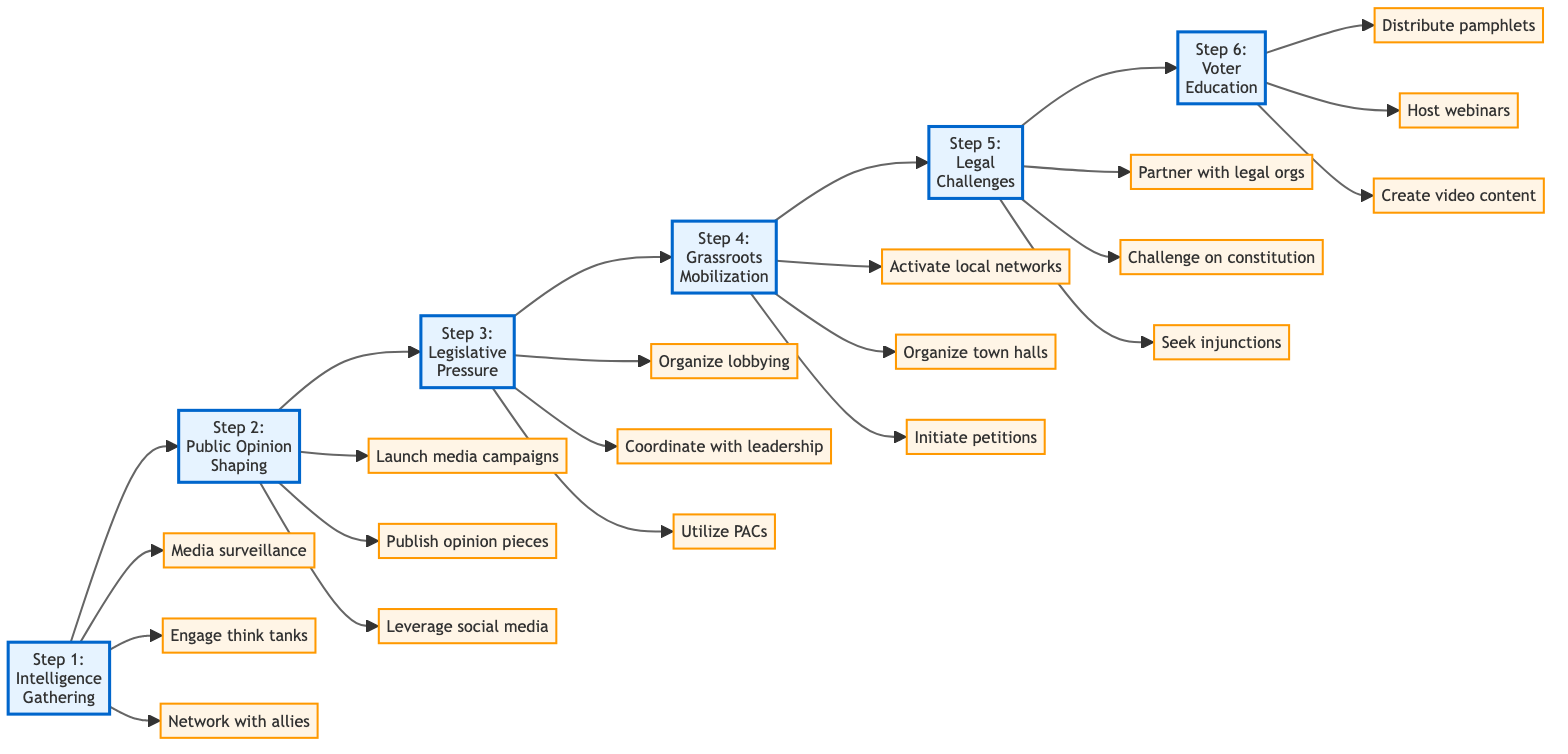What is the first step in counteracting electoral reform proposals? The first step is labeled "Step 1: Intelligence Gathering," as it appears at the beginning of the flowchart.
Answer: Intelligence Gathering How many steps are there in the diagram? By counting the nodes connected horizontally in the flowchart, we can see there are six steps.
Answer: 6 What action is associated with Step 3? In Step 3, the actions listed include organizing lobbying efforts, coordinating with leadership, and utilizing PACs, identifying any of these actions will respond to the question.
Answer: Organize lobbying Which step comes after Step 4? By looking at the flow from Step 4, it flows directly to Step 5 which is labeled "Legal Challenges."
Answer: Legal Challenges What is the overall goal of the flowchart? The flowchart guides the user through steps to counteract electoral reform proposals, indicating that the aim is to resist proposed changes to the electoral system.
Answer: Counteract electoral reforms How does Step 2 relate to public opinion? Step 2 is explicitly focused on shaping public opinion, indicating its central role in creating resistance against proposed reforms.
Answer: Shape public opinion What is the last action taken in the process? The last action linked to Step 6 is "Create educational content for YouTube and other video platforms,” marking it as the final action in the flowchart.
Answer: Create educational content What step includes grassroots mobilization? Grassroots mobilization is encapsulated in Step 4, which directly addresses mobilizing community action against electoral reforms.
Answer: Step 4 What kind of organizations are suggested in Step 5 for legal challenges? Partnering with conservative legal organizations such as the Federalist Society is suggested in Step 5 for pursuing legal challenges against reforms.
Answer: Conservative legal organizations 